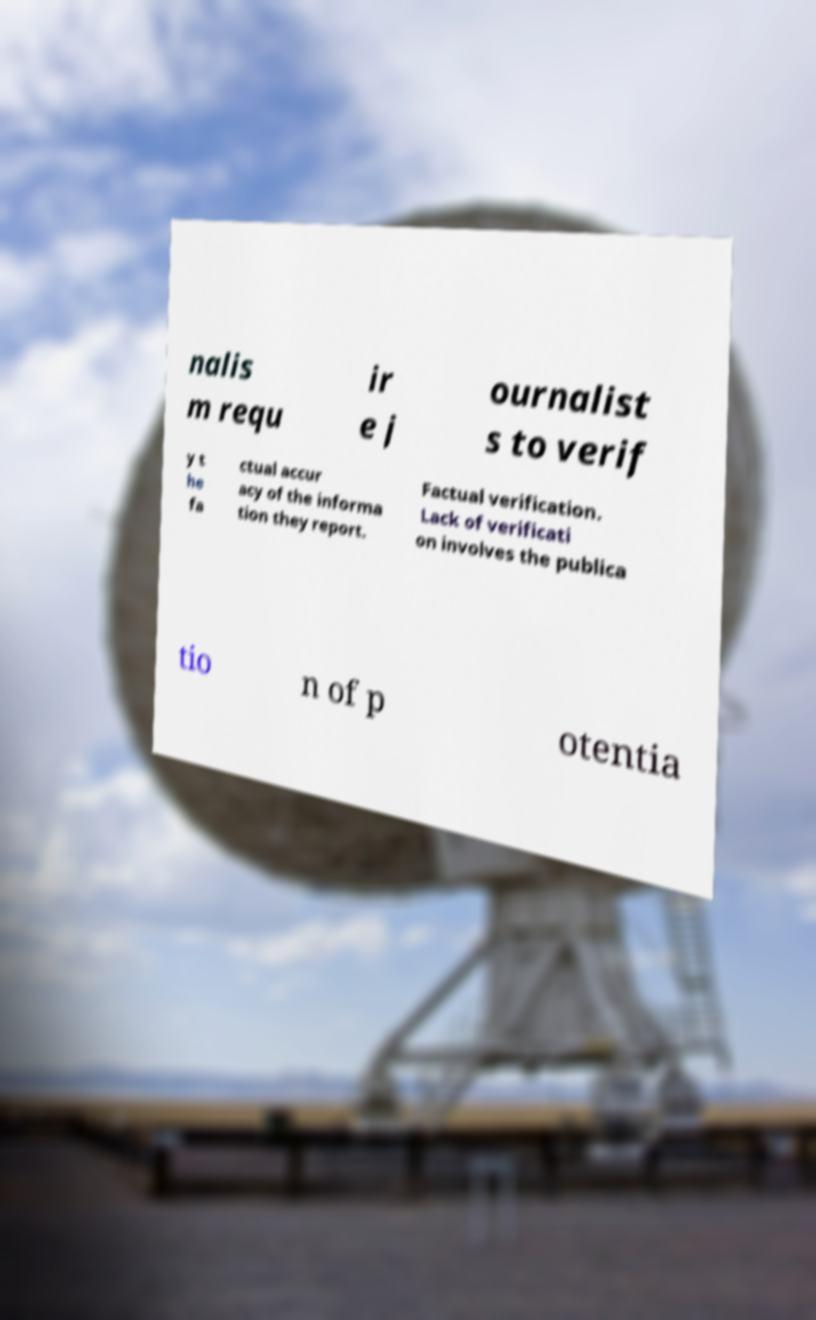What messages or text are displayed in this image? I need them in a readable, typed format. nalis m requ ir e j ournalist s to verif y t he fa ctual accur acy of the informa tion they report. Factual verification. Lack of verificati on involves the publica tio n of p otentia 